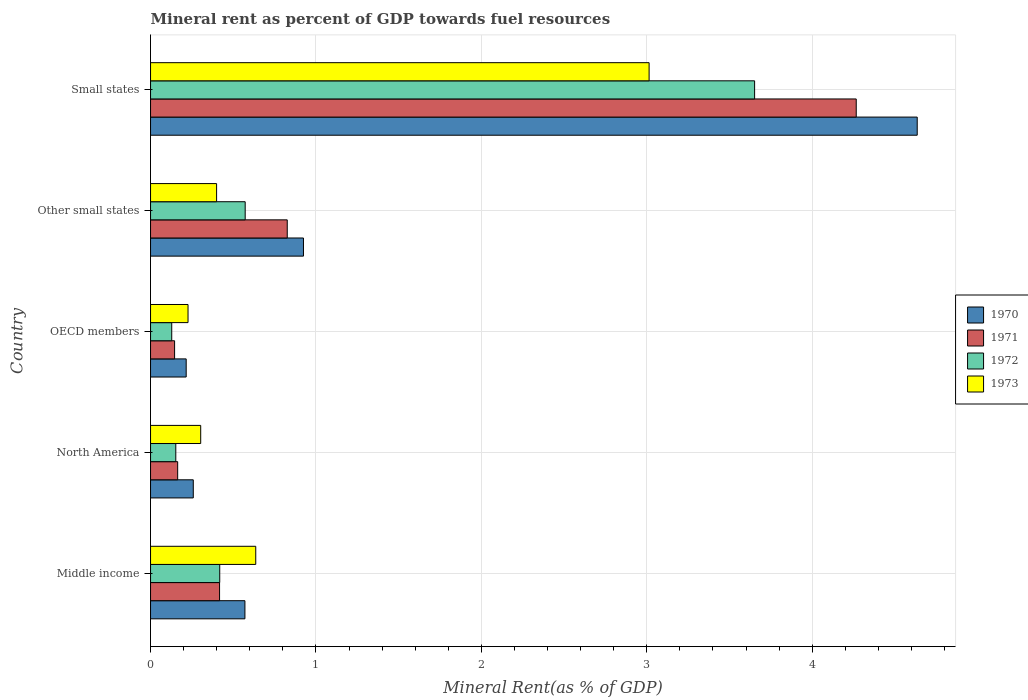How many different coloured bars are there?
Your response must be concise. 4. Are the number of bars per tick equal to the number of legend labels?
Your response must be concise. Yes. Are the number of bars on each tick of the Y-axis equal?
Your answer should be compact. Yes. What is the label of the 1st group of bars from the top?
Give a very brief answer. Small states. What is the mineral rent in 1971 in North America?
Provide a succinct answer. 0.16. Across all countries, what is the maximum mineral rent in 1971?
Make the answer very short. 4.27. Across all countries, what is the minimum mineral rent in 1970?
Your answer should be very brief. 0.22. In which country was the mineral rent in 1972 maximum?
Your response must be concise. Small states. In which country was the mineral rent in 1972 minimum?
Give a very brief answer. OECD members. What is the total mineral rent in 1973 in the graph?
Provide a succinct answer. 4.58. What is the difference between the mineral rent in 1971 in Middle income and that in Small states?
Offer a terse response. -3.85. What is the difference between the mineral rent in 1971 in Middle income and the mineral rent in 1972 in Small states?
Your answer should be compact. -3.23. What is the average mineral rent in 1973 per country?
Ensure brevity in your answer.  0.92. What is the difference between the mineral rent in 1970 and mineral rent in 1972 in North America?
Offer a very short reply. 0.11. What is the ratio of the mineral rent in 1972 in Middle income to that in OECD members?
Your answer should be very brief. 3.26. What is the difference between the highest and the second highest mineral rent in 1970?
Your answer should be very brief. 3.71. What is the difference between the highest and the lowest mineral rent in 1972?
Give a very brief answer. 3.52. In how many countries, is the mineral rent in 1971 greater than the average mineral rent in 1971 taken over all countries?
Provide a short and direct response. 1. Is it the case that in every country, the sum of the mineral rent in 1971 and mineral rent in 1973 is greater than the sum of mineral rent in 1970 and mineral rent in 1972?
Your response must be concise. Yes. How many bars are there?
Ensure brevity in your answer.  20. Are the values on the major ticks of X-axis written in scientific E-notation?
Your answer should be compact. No. Does the graph contain grids?
Ensure brevity in your answer.  Yes. Where does the legend appear in the graph?
Offer a very short reply. Center right. How are the legend labels stacked?
Your response must be concise. Vertical. What is the title of the graph?
Your answer should be very brief. Mineral rent as percent of GDP towards fuel resources. What is the label or title of the X-axis?
Ensure brevity in your answer.  Mineral Rent(as % of GDP). What is the label or title of the Y-axis?
Ensure brevity in your answer.  Country. What is the Mineral Rent(as % of GDP) of 1970 in Middle income?
Ensure brevity in your answer.  0.57. What is the Mineral Rent(as % of GDP) of 1971 in Middle income?
Provide a short and direct response. 0.42. What is the Mineral Rent(as % of GDP) in 1972 in Middle income?
Provide a short and direct response. 0.42. What is the Mineral Rent(as % of GDP) in 1973 in Middle income?
Provide a succinct answer. 0.64. What is the Mineral Rent(as % of GDP) in 1970 in North America?
Your response must be concise. 0.26. What is the Mineral Rent(as % of GDP) in 1971 in North America?
Keep it short and to the point. 0.16. What is the Mineral Rent(as % of GDP) of 1972 in North America?
Ensure brevity in your answer.  0.15. What is the Mineral Rent(as % of GDP) in 1973 in North America?
Provide a succinct answer. 0.3. What is the Mineral Rent(as % of GDP) in 1970 in OECD members?
Give a very brief answer. 0.22. What is the Mineral Rent(as % of GDP) of 1971 in OECD members?
Offer a very short reply. 0.15. What is the Mineral Rent(as % of GDP) in 1972 in OECD members?
Offer a terse response. 0.13. What is the Mineral Rent(as % of GDP) of 1973 in OECD members?
Your answer should be very brief. 0.23. What is the Mineral Rent(as % of GDP) in 1970 in Other small states?
Give a very brief answer. 0.92. What is the Mineral Rent(as % of GDP) of 1971 in Other small states?
Provide a short and direct response. 0.83. What is the Mineral Rent(as % of GDP) in 1972 in Other small states?
Your answer should be compact. 0.57. What is the Mineral Rent(as % of GDP) of 1973 in Other small states?
Make the answer very short. 0.4. What is the Mineral Rent(as % of GDP) of 1970 in Small states?
Ensure brevity in your answer.  4.63. What is the Mineral Rent(as % of GDP) of 1971 in Small states?
Your answer should be very brief. 4.27. What is the Mineral Rent(as % of GDP) of 1972 in Small states?
Offer a very short reply. 3.65. What is the Mineral Rent(as % of GDP) in 1973 in Small states?
Your answer should be very brief. 3.01. Across all countries, what is the maximum Mineral Rent(as % of GDP) in 1970?
Make the answer very short. 4.63. Across all countries, what is the maximum Mineral Rent(as % of GDP) in 1971?
Provide a succinct answer. 4.27. Across all countries, what is the maximum Mineral Rent(as % of GDP) in 1972?
Provide a short and direct response. 3.65. Across all countries, what is the maximum Mineral Rent(as % of GDP) of 1973?
Give a very brief answer. 3.01. Across all countries, what is the minimum Mineral Rent(as % of GDP) of 1970?
Keep it short and to the point. 0.22. Across all countries, what is the minimum Mineral Rent(as % of GDP) in 1971?
Your answer should be compact. 0.15. Across all countries, what is the minimum Mineral Rent(as % of GDP) in 1972?
Provide a short and direct response. 0.13. Across all countries, what is the minimum Mineral Rent(as % of GDP) in 1973?
Provide a short and direct response. 0.23. What is the total Mineral Rent(as % of GDP) of 1970 in the graph?
Offer a terse response. 6.6. What is the total Mineral Rent(as % of GDP) in 1971 in the graph?
Keep it short and to the point. 5.82. What is the total Mineral Rent(as % of GDP) of 1972 in the graph?
Your answer should be compact. 4.92. What is the total Mineral Rent(as % of GDP) in 1973 in the graph?
Keep it short and to the point. 4.58. What is the difference between the Mineral Rent(as % of GDP) of 1970 in Middle income and that in North America?
Offer a very short reply. 0.31. What is the difference between the Mineral Rent(as % of GDP) of 1971 in Middle income and that in North America?
Offer a terse response. 0.25. What is the difference between the Mineral Rent(as % of GDP) of 1972 in Middle income and that in North America?
Your response must be concise. 0.27. What is the difference between the Mineral Rent(as % of GDP) in 1973 in Middle income and that in North America?
Give a very brief answer. 0.33. What is the difference between the Mineral Rent(as % of GDP) in 1970 in Middle income and that in OECD members?
Offer a very short reply. 0.35. What is the difference between the Mineral Rent(as % of GDP) of 1971 in Middle income and that in OECD members?
Offer a terse response. 0.27. What is the difference between the Mineral Rent(as % of GDP) in 1972 in Middle income and that in OECD members?
Your response must be concise. 0.29. What is the difference between the Mineral Rent(as % of GDP) of 1973 in Middle income and that in OECD members?
Your answer should be compact. 0.41. What is the difference between the Mineral Rent(as % of GDP) of 1970 in Middle income and that in Other small states?
Your answer should be compact. -0.35. What is the difference between the Mineral Rent(as % of GDP) of 1971 in Middle income and that in Other small states?
Ensure brevity in your answer.  -0.41. What is the difference between the Mineral Rent(as % of GDP) in 1972 in Middle income and that in Other small states?
Your answer should be compact. -0.15. What is the difference between the Mineral Rent(as % of GDP) in 1973 in Middle income and that in Other small states?
Offer a terse response. 0.24. What is the difference between the Mineral Rent(as % of GDP) in 1970 in Middle income and that in Small states?
Your answer should be very brief. -4.06. What is the difference between the Mineral Rent(as % of GDP) in 1971 in Middle income and that in Small states?
Ensure brevity in your answer.  -3.85. What is the difference between the Mineral Rent(as % of GDP) of 1972 in Middle income and that in Small states?
Offer a very short reply. -3.23. What is the difference between the Mineral Rent(as % of GDP) of 1973 in Middle income and that in Small states?
Your response must be concise. -2.38. What is the difference between the Mineral Rent(as % of GDP) in 1970 in North America and that in OECD members?
Your answer should be very brief. 0.04. What is the difference between the Mineral Rent(as % of GDP) in 1971 in North America and that in OECD members?
Make the answer very short. 0.02. What is the difference between the Mineral Rent(as % of GDP) of 1972 in North America and that in OECD members?
Make the answer very short. 0.02. What is the difference between the Mineral Rent(as % of GDP) of 1973 in North America and that in OECD members?
Offer a terse response. 0.08. What is the difference between the Mineral Rent(as % of GDP) in 1970 in North America and that in Other small states?
Offer a very short reply. -0.67. What is the difference between the Mineral Rent(as % of GDP) of 1971 in North America and that in Other small states?
Ensure brevity in your answer.  -0.66. What is the difference between the Mineral Rent(as % of GDP) in 1972 in North America and that in Other small states?
Your answer should be compact. -0.42. What is the difference between the Mineral Rent(as % of GDP) in 1973 in North America and that in Other small states?
Provide a short and direct response. -0.1. What is the difference between the Mineral Rent(as % of GDP) of 1970 in North America and that in Small states?
Provide a short and direct response. -4.38. What is the difference between the Mineral Rent(as % of GDP) of 1971 in North America and that in Small states?
Your response must be concise. -4.1. What is the difference between the Mineral Rent(as % of GDP) in 1972 in North America and that in Small states?
Give a very brief answer. -3.5. What is the difference between the Mineral Rent(as % of GDP) in 1973 in North America and that in Small states?
Keep it short and to the point. -2.71. What is the difference between the Mineral Rent(as % of GDP) of 1970 in OECD members and that in Other small states?
Keep it short and to the point. -0.71. What is the difference between the Mineral Rent(as % of GDP) in 1971 in OECD members and that in Other small states?
Your answer should be very brief. -0.68. What is the difference between the Mineral Rent(as % of GDP) in 1972 in OECD members and that in Other small states?
Give a very brief answer. -0.44. What is the difference between the Mineral Rent(as % of GDP) of 1973 in OECD members and that in Other small states?
Offer a very short reply. -0.17. What is the difference between the Mineral Rent(as % of GDP) of 1970 in OECD members and that in Small states?
Your response must be concise. -4.42. What is the difference between the Mineral Rent(as % of GDP) of 1971 in OECD members and that in Small states?
Your answer should be compact. -4.12. What is the difference between the Mineral Rent(as % of GDP) of 1972 in OECD members and that in Small states?
Ensure brevity in your answer.  -3.52. What is the difference between the Mineral Rent(as % of GDP) in 1973 in OECD members and that in Small states?
Keep it short and to the point. -2.79. What is the difference between the Mineral Rent(as % of GDP) in 1970 in Other small states and that in Small states?
Keep it short and to the point. -3.71. What is the difference between the Mineral Rent(as % of GDP) of 1971 in Other small states and that in Small states?
Give a very brief answer. -3.44. What is the difference between the Mineral Rent(as % of GDP) of 1972 in Other small states and that in Small states?
Your answer should be compact. -3.08. What is the difference between the Mineral Rent(as % of GDP) of 1973 in Other small states and that in Small states?
Provide a succinct answer. -2.61. What is the difference between the Mineral Rent(as % of GDP) in 1970 in Middle income and the Mineral Rent(as % of GDP) in 1971 in North America?
Offer a very short reply. 0.41. What is the difference between the Mineral Rent(as % of GDP) in 1970 in Middle income and the Mineral Rent(as % of GDP) in 1972 in North America?
Your response must be concise. 0.42. What is the difference between the Mineral Rent(as % of GDP) of 1970 in Middle income and the Mineral Rent(as % of GDP) of 1973 in North America?
Keep it short and to the point. 0.27. What is the difference between the Mineral Rent(as % of GDP) of 1971 in Middle income and the Mineral Rent(as % of GDP) of 1972 in North America?
Your answer should be very brief. 0.26. What is the difference between the Mineral Rent(as % of GDP) in 1971 in Middle income and the Mineral Rent(as % of GDP) in 1973 in North America?
Your answer should be compact. 0.11. What is the difference between the Mineral Rent(as % of GDP) of 1972 in Middle income and the Mineral Rent(as % of GDP) of 1973 in North America?
Ensure brevity in your answer.  0.12. What is the difference between the Mineral Rent(as % of GDP) of 1970 in Middle income and the Mineral Rent(as % of GDP) of 1971 in OECD members?
Offer a very short reply. 0.43. What is the difference between the Mineral Rent(as % of GDP) in 1970 in Middle income and the Mineral Rent(as % of GDP) in 1972 in OECD members?
Keep it short and to the point. 0.44. What is the difference between the Mineral Rent(as % of GDP) of 1970 in Middle income and the Mineral Rent(as % of GDP) of 1973 in OECD members?
Offer a terse response. 0.34. What is the difference between the Mineral Rent(as % of GDP) in 1971 in Middle income and the Mineral Rent(as % of GDP) in 1972 in OECD members?
Provide a succinct answer. 0.29. What is the difference between the Mineral Rent(as % of GDP) of 1971 in Middle income and the Mineral Rent(as % of GDP) of 1973 in OECD members?
Make the answer very short. 0.19. What is the difference between the Mineral Rent(as % of GDP) of 1972 in Middle income and the Mineral Rent(as % of GDP) of 1973 in OECD members?
Make the answer very short. 0.19. What is the difference between the Mineral Rent(as % of GDP) of 1970 in Middle income and the Mineral Rent(as % of GDP) of 1971 in Other small states?
Ensure brevity in your answer.  -0.26. What is the difference between the Mineral Rent(as % of GDP) of 1970 in Middle income and the Mineral Rent(as % of GDP) of 1972 in Other small states?
Provide a succinct answer. -0. What is the difference between the Mineral Rent(as % of GDP) of 1970 in Middle income and the Mineral Rent(as % of GDP) of 1973 in Other small states?
Provide a short and direct response. 0.17. What is the difference between the Mineral Rent(as % of GDP) in 1971 in Middle income and the Mineral Rent(as % of GDP) in 1972 in Other small states?
Your answer should be very brief. -0.15. What is the difference between the Mineral Rent(as % of GDP) in 1971 in Middle income and the Mineral Rent(as % of GDP) in 1973 in Other small states?
Make the answer very short. 0.02. What is the difference between the Mineral Rent(as % of GDP) in 1972 in Middle income and the Mineral Rent(as % of GDP) in 1973 in Other small states?
Provide a succinct answer. 0.02. What is the difference between the Mineral Rent(as % of GDP) in 1970 in Middle income and the Mineral Rent(as % of GDP) in 1971 in Small states?
Your response must be concise. -3.7. What is the difference between the Mineral Rent(as % of GDP) in 1970 in Middle income and the Mineral Rent(as % of GDP) in 1972 in Small states?
Provide a succinct answer. -3.08. What is the difference between the Mineral Rent(as % of GDP) of 1970 in Middle income and the Mineral Rent(as % of GDP) of 1973 in Small states?
Offer a terse response. -2.44. What is the difference between the Mineral Rent(as % of GDP) in 1971 in Middle income and the Mineral Rent(as % of GDP) in 1972 in Small states?
Ensure brevity in your answer.  -3.23. What is the difference between the Mineral Rent(as % of GDP) of 1971 in Middle income and the Mineral Rent(as % of GDP) of 1973 in Small states?
Ensure brevity in your answer.  -2.6. What is the difference between the Mineral Rent(as % of GDP) of 1972 in Middle income and the Mineral Rent(as % of GDP) of 1973 in Small states?
Ensure brevity in your answer.  -2.6. What is the difference between the Mineral Rent(as % of GDP) in 1970 in North America and the Mineral Rent(as % of GDP) in 1971 in OECD members?
Your answer should be very brief. 0.11. What is the difference between the Mineral Rent(as % of GDP) of 1970 in North America and the Mineral Rent(as % of GDP) of 1972 in OECD members?
Provide a short and direct response. 0.13. What is the difference between the Mineral Rent(as % of GDP) of 1970 in North America and the Mineral Rent(as % of GDP) of 1973 in OECD members?
Offer a terse response. 0.03. What is the difference between the Mineral Rent(as % of GDP) in 1971 in North America and the Mineral Rent(as % of GDP) in 1972 in OECD members?
Ensure brevity in your answer.  0.04. What is the difference between the Mineral Rent(as % of GDP) of 1971 in North America and the Mineral Rent(as % of GDP) of 1973 in OECD members?
Ensure brevity in your answer.  -0.06. What is the difference between the Mineral Rent(as % of GDP) in 1972 in North America and the Mineral Rent(as % of GDP) in 1973 in OECD members?
Provide a short and direct response. -0.07. What is the difference between the Mineral Rent(as % of GDP) of 1970 in North America and the Mineral Rent(as % of GDP) of 1971 in Other small states?
Ensure brevity in your answer.  -0.57. What is the difference between the Mineral Rent(as % of GDP) of 1970 in North America and the Mineral Rent(as % of GDP) of 1972 in Other small states?
Your answer should be very brief. -0.31. What is the difference between the Mineral Rent(as % of GDP) of 1970 in North America and the Mineral Rent(as % of GDP) of 1973 in Other small states?
Make the answer very short. -0.14. What is the difference between the Mineral Rent(as % of GDP) in 1971 in North America and the Mineral Rent(as % of GDP) in 1972 in Other small states?
Your answer should be very brief. -0.41. What is the difference between the Mineral Rent(as % of GDP) in 1971 in North America and the Mineral Rent(as % of GDP) in 1973 in Other small states?
Your response must be concise. -0.24. What is the difference between the Mineral Rent(as % of GDP) in 1972 in North America and the Mineral Rent(as % of GDP) in 1973 in Other small states?
Your response must be concise. -0.25. What is the difference between the Mineral Rent(as % of GDP) of 1970 in North America and the Mineral Rent(as % of GDP) of 1971 in Small states?
Provide a succinct answer. -4.01. What is the difference between the Mineral Rent(as % of GDP) of 1970 in North America and the Mineral Rent(as % of GDP) of 1972 in Small states?
Your answer should be very brief. -3.39. What is the difference between the Mineral Rent(as % of GDP) in 1970 in North America and the Mineral Rent(as % of GDP) in 1973 in Small states?
Your response must be concise. -2.76. What is the difference between the Mineral Rent(as % of GDP) of 1971 in North America and the Mineral Rent(as % of GDP) of 1972 in Small states?
Offer a terse response. -3.49. What is the difference between the Mineral Rent(as % of GDP) in 1971 in North America and the Mineral Rent(as % of GDP) in 1973 in Small states?
Make the answer very short. -2.85. What is the difference between the Mineral Rent(as % of GDP) in 1972 in North America and the Mineral Rent(as % of GDP) in 1973 in Small states?
Your response must be concise. -2.86. What is the difference between the Mineral Rent(as % of GDP) in 1970 in OECD members and the Mineral Rent(as % of GDP) in 1971 in Other small states?
Give a very brief answer. -0.61. What is the difference between the Mineral Rent(as % of GDP) in 1970 in OECD members and the Mineral Rent(as % of GDP) in 1972 in Other small states?
Your answer should be compact. -0.36. What is the difference between the Mineral Rent(as % of GDP) in 1970 in OECD members and the Mineral Rent(as % of GDP) in 1973 in Other small states?
Provide a short and direct response. -0.18. What is the difference between the Mineral Rent(as % of GDP) in 1971 in OECD members and the Mineral Rent(as % of GDP) in 1972 in Other small states?
Keep it short and to the point. -0.43. What is the difference between the Mineral Rent(as % of GDP) in 1971 in OECD members and the Mineral Rent(as % of GDP) in 1973 in Other small states?
Offer a very short reply. -0.25. What is the difference between the Mineral Rent(as % of GDP) in 1972 in OECD members and the Mineral Rent(as % of GDP) in 1973 in Other small states?
Ensure brevity in your answer.  -0.27. What is the difference between the Mineral Rent(as % of GDP) in 1970 in OECD members and the Mineral Rent(as % of GDP) in 1971 in Small states?
Provide a succinct answer. -4.05. What is the difference between the Mineral Rent(as % of GDP) of 1970 in OECD members and the Mineral Rent(as % of GDP) of 1972 in Small states?
Make the answer very short. -3.44. What is the difference between the Mineral Rent(as % of GDP) of 1970 in OECD members and the Mineral Rent(as % of GDP) of 1973 in Small states?
Offer a very short reply. -2.8. What is the difference between the Mineral Rent(as % of GDP) of 1971 in OECD members and the Mineral Rent(as % of GDP) of 1972 in Small states?
Provide a succinct answer. -3.51. What is the difference between the Mineral Rent(as % of GDP) in 1971 in OECD members and the Mineral Rent(as % of GDP) in 1973 in Small states?
Give a very brief answer. -2.87. What is the difference between the Mineral Rent(as % of GDP) of 1972 in OECD members and the Mineral Rent(as % of GDP) of 1973 in Small states?
Your answer should be compact. -2.89. What is the difference between the Mineral Rent(as % of GDP) of 1970 in Other small states and the Mineral Rent(as % of GDP) of 1971 in Small states?
Your answer should be compact. -3.34. What is the difference between the Mineral Rent(as % of GDP) of 1970 in Other small states and the Mineral Rent(as % of GDP) of 1972 in Small states?
Provide a short and direct response. -2.73. What is the difference between the Mineral Rent(as % of GDP) of 1970 in Other small states and the Mineral Rent(as % of GDP) of 1973 in Small states?
Keep it short and to the point. -2.09. What is the difference between the Mineral Rent(as % of GDP) in 1971 in Other small states and the Mineral Rent(as % of GDP) in 1972 in Small states?
Provide a succinct answer. -2.83. What is the difference between the Mineral Rent(as % of GDP) of 1971 in Other small states and the Mineral Rent(as % of GDP) of 1973 in Small states?
Your answer should be compact. -2.19. What is the difference between the Mineral Rent(as % of GDP) of 1972 in Other small states and the Mineral Rent(as % of GDP) of 1973 in Small states?
Ensure brevity in your answer.  -2.44. What is the average Mineral Rent(as % of GDP) of 1970 per country?
Your answer should be very brief. 1.32. What is the average Mineral Rent(as % of GDP) in 1971 per country?
Keep it short and to the point. 1.16. What is the average Mineral Rent(as % of GDP) of 1972 per country?
Your answer should be compact. 0.98. What is the average Mineral Rent(as % of GDP) in 1973 per country?
Your response must be concise. 0.92. What is the difference between the Mineral Rent(as % of GDP) in 1970 and Mineral Rent(as % of GDP) in 1971 in Middle income?
Keep it short and to the point. 0.15. What is the difference between the Mineral Rent(as % of GDP) in 1970 and Mineral Rent(as % of GDP) in 1972 in Middle income?
Your answer should be compact. 0.15. What is the difference between the Mineral Rent(as % of GDP) of 1970 and Mineral Rent(as % of GDP) of 1973 in Middle income?
Your response must be concise. -0.07. What is the difference between the Mineral Rent(as % of GDP) in 1971 and Mineral Rent(as % of GDP) in 1972 in Middle income?
Keep it short and to the point. -0. What is the difference between the Mineral Rent(as % of GDP) in 1971 and Mineral Rent(as % of GDP) in 1973 in Middle income?
Keep it short and to the point. -0.22. What is the difference between the Mineral Rent(as % of GDP) in 1972 and Mineral Rent(as % of GDP) in 1973 in Middle income?
Your answer should be very brief. -0.22. What is the difference between the Mineral Rent(as % of GDP) of 1970 and Mineral Rent(as % of GDP) of 1971 in North America?
Offer a very short reply. 0.09. What is the difference between the Mineral Rent(as % of GDP) in 1970 and Mineral Rent(as % of GDP) in 1972 in North America?
Your response must be concise. 0.11. What is the difference between the Mineral Rent(as % of GDP) in 1970 and Mineral Rent(as % of GDP) in 1973 in North America?
Provide a succinct answer. -0.04. What is the difference between the Mineral Rent(as % of GDP) of 1971 and Mineral Rent(as % of GDP) of 1972 in North America?
Offer a terse response. 0.01. What is the difference between the Mineral Rent(as % of GDP) in 1971 and Mineral Rent(as % of GDP) in 1973 in North America?
Keep it short and to the point. -0.14. What is the difference between the Mineral Rent(as % of GDP) in 1972 and Mineral Rent(as % of GDP) in 1973 in North America?
Your response must be concise. -0.15. What is the difference between the Mineral Rent(as % of GDP) of 1970 and Mineral Rent(as % of GDP) of 1971 in OECD members?
Your answer should be compact. 0.07. What is the difference between the Mineral Rent(as % of GDP) of 1970 and Mineral Rent(as % of GDP) of 1972 in OECD members?
Your response must be concise. 0.09. What is the difference between the Mineral Rent(as % of GDP) in 1970 and Mineral Rent(as % of GDP) in 1973 in OECD members?
Your answer should be compact. -0.01. What is the difference between the Mineral Rent(as % of GDP) of 1971 and Mineral Rent(as % of GDP) of 1972 in OECD members?
Provide a succinct answer. 0.02. What is the difference between the Mineral Rent(as % of GDP) of 1971 and Mineral Rent(as % of GDP) of 1973 in OECD members?
Keep it short and to the point. -0.08. What is the difference between the Mineral Rent(as % of GDP) in 1972 and Mineral Rent(as % of GDP) in 1973 in OECD members?
Give a very brief answer. -0.1. What is the difference between the Mineral Rent(as % of GDP) in 1970 and Mineral Rent(as % of GDP) in 1971 in Other small states?
Provide a succinct answer. 0.1. What is the difference between the Mineral Rent(as % of GDP) in 1970 and Mineral Rent(as % of GDP) in 1972 in Other small states?
Your response must be concise. 0.35. What is the difference between the Mineral Rent(as % of GDP) in 1970 and Mineral Rent(as % of GDP) in 1973 in Other small states?
Your answer should be compact. 0.53. What is the difference between the Mineral Rent(as % of GDP) in 1971 and Mineral Rent(as % of GDP) in 1972 in Other small states?
Keep it short and to the point. 0.25. What is the difference between the Mineral Rent(as % of GDP) in 1971 and Mineral Rent(as % of GDP) in 1973 in Other small states?
Keep it short and to the point. 0.43. What is the difference between the Mineral Rent(as % of GDP) in 1972 and Mineral Rent(as % of GDP) in 1973 in Other small states?
Provide a short and direct response. 0.17. What is the difference between the Mineral Rent(as % of GDP) in 1970 and Mineral Rent(as % of GDP) in 1971 in Small states?
Give a very brief answer. 0.37. What is the difference between the Mineral Rent(as % of GDP) in 1970 and Mineral Rent(as % of GDP) in 1972 in Small states?
Your response must be concise. 0.98. What is the difference between the Mineral Rent(as % of GDP) in 1970 and Mineral Rent(as % of GDP) in 1973 in Small states?
Your answer should be compact. 1.62. What is the difference between the Mineral Rent(as % of GDP) of 1971 and Mineral Rent(as % of GDP) of 1972 in Small states?
Your answer should be very brief. 0.61. What is the difference between the Mineral Rent(as % of GDP) of 1971 and Mineral Rent(as % of GDP) of 1973 in Small states?
Offer a very short reply. 1.25. What is the difference between the Mineral Rent(as % of GDP) of 1972 and Mineral Rent(as % of GDP) of 1973 in Small states?
Give a very brief answer. 0.64. What is the ratio of the Mineral Rent(as % of GDP) of 1970 in Middle income to that in North America?
Ensure brevity in your answer.  2.21. What is the ratio of the Mineral Rent(as % of GDP) in 1971 in Middle income to that in North America?
Offer a very short reply. 2.54. What is the ratio of the Mineral Rent(as % of GDP) in 1972 in Middle income to that in North America?
Ensure brevity in your answer.  2.74. What is the ratio of the Mineral Rent(as % of GDP) of 1973 in Middle income to that in North America?
Your answer should be compact. 2.1. What is the ratio of the Mineral Rent(as % of GDP) of 1970 in Middle income to that in OECD members?
Your answer should be compact. 2.65. What is the ratio of the Mineral Rent(as % of GDP) of 1971 in Middle income to that in OECD members?
Provide a succinct answer. 2.87. What is the ratio of the Mineral Rent(as % of GDP) of 1972 in Middle income to that in OECD members?
Provide a succinct answer. 3.26. What is the ratio of the Mineral Rent(as % of GDP) in 1973 in Middle income to that in OECD members?
Offer a very short reply. 2.81. What is the ratio of the Mineral Rent(as % of GDP) in 1970 in Middle income to that in Other small states?
Offer a terse response. 0.62. What is the ratio of the Mineral Rent(as % of GDP) of 1971 in Middle income to that in Other small states?
Ensure brevity in your answer.  0.5. What is the ratio of the Mineral Rent(as % of GDP) in 1972 in Middle income to that in Other small states?
Make the answer very short. 0.73. What is the ratio of the Mineral Rent(as % of GDP) of 1973 in Middle income to that in Other small states?
Give a very brief answer. 1.59. What is the ratio of the Mineral Rent(as % of GDP) in 1970 in Middle income to that in Small states?
Your answer should be compact. 0.12. What is the ratio of the Mineral Rent(as % of GDP) of 1971 in Middle income to that in Small states?
Provide a short and direct response. 0.1. What is the ratio of the Mineral Rent(as % of GDP) of 1972 in Middle income to that in Small states?
Keep it short and to the point. 0.11. What is the ratio of the Mineral Rent(as % of GDP) of 1973 in Middle income to that in Small states?
Offer a terse response. 0.21. What is the ratio of the Mineral Rent(as % of GDP) of 1970 in North America to that in OECD members?
Make the answer very short. 1.2. What is the ratio of the Mineral Rent(as % of GDP) in 1971 in North America to that in OECD members?
Ensure brevity in your answer.  1.13. What is the ratio of the Mineral Rent(as % of GDP) in 1972 in North America to that in OECD members?
Provide a succinct answer. 1.19. What is the ratio of the Mineral Rent(as % of GDP) of 1973 in North America to that in OECD members?
Your response must be concise. 1.34. What is the ratio of the Mineral Rent(as % of GDP) of 1970 in North America to that in Other small states?
Provide a short and direct response. 0.28. What is the ratio of the Mineral Rent(as % of GDP) in 1971 in North America to that in Other small states?
Your answer should be very brief. 0.2. What is the ratio of the Mineral Rent(as % of GDP) of 1972 in North America to that in Other small states?
Keep it short and to the point. 0.27. What is the ratio of the Mineral Rent(as % of GDP) in 1973 in North America to that in Other small states?
Ensure brevity in your answer.  0.76. What is the ratio of the Mineral Rent(as % of GDP) in 1970 in North America to that in Small states?
Make the answer very short. 0.06. What is the ratio of the Mineral Rent(as % of GDP) in 1971 in North America to that in Small states?
Provide a short and direct response. 0.04. What is the ratio of the Mineral Rent(as % of GDP) of 1972 in North America to that in Small states?
Provide a short and direct response. 0.04. What is the ratio of the Mineral Rent(as % of GDP) in 1973 in North America to that in Small states?
Your answer should be compact. 0.1. What is the ratio of the Mineral Rent(as % of GDP) in 1970 in OECD members to that in Other small states?
Ensure brevity in your answer.  0.23. What is the ratio of the Mineral Rent(as % of GDP) in 1971 in OECD members to that in Other small states?
Provide a succinct answer. 0.18. What is the ratio of the Mineral Rent(as % of GDP) of 1972 in OECD members to that in Other small states?
Give a very brief answer. 0.22. What is the ratio of the Mineral Rent(as % of GDP) of 1973 in OECD members to that in Other small states?
Your answer should be very brief. 0.57. What is the ratio of the Mineral Rent(as % of GDP) in 1970 in OECD members to that in Small states?
Keep it short and to the point. 0.05. What is the ratio of the Mineral Rent(as % of GDP) of 1971 in OECD members to that in Small states?
Give a very brief answer. 0.03. What is the ratio of the Mineral Rent(as % of GDP) in 1972 in OECD members to that in Small states?
Offer a very short reply. 0.04. What is the ratio of the Mineral Rent(as % of GDP) of 1973 in OECD members to that in Small states?
Give a very brief answer. 0.08. What is the ratio of the Mineral Rent(as % of GDP) in 1970 in Other small states to that in Small states?
Your response must be concise. 0.2. What is the ratio of the Mineral Rent(as % of GDP) in 1971 in Other small states to that in Small states?
Your response must be concise. 0.19. What is the ratio of the Mineral Rent(as % of GDP) in 1972 in Other small states to that in Small states?
Your answer should be compact. 0.16. What is the ratio of the Mineral Rent(as % of GDP) of 1973 in Other small states to that in Small states?
Your answer should be very brief. 0.13. What is the difference between the highest and the second highest Mineral Rent(as % of GDP) of 1970?
Your answer should be compact. 3.71. What is the difference between the highest and the second highest Mineral Rent(as % of GDP) of 1971?
Keep it short and to the point. 3.44. What is the difference between the highest and the second highest Mineral Rent(as % of GDP) in 1972?
Your response must be concise. 3.08. What is the difference between the highest and the second highest Mineral Rent(as % of GDP) in 1973?
Your answer should be compact. 2.38. What is the difference between the highest and the lowest Mineral Rent(as % of GDP) in 1970?
Make the answer very short. 4.42. What is the difference between the highest and the lowest Mineral Rent(as % of GDP) of 1971?
Provide a succinct answer. 4.12. What is the difference between the highest and the lowest Mineral Rent(as % of GDP) in 1972?
Offer a terse response. 3.52. What is the difference between the highest and the lowest Mineral Rent(as % of GDP) in 1973?
Offer a terse response. 2.79. 